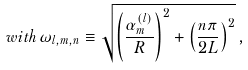Convert formula to latex. <formula><loc_0><loc_0><loc_500><loc_500>w i t h \, \omega _ { l , m , n } \equiv \sqrt { \left ( \frac { \alpha _ { m } ^ { ( l ) } } R \right ) ^ { 2 } + \left ( \frac { n \pi } { 2 L } \right ) ^ { 2 } } \, ,</formula> 